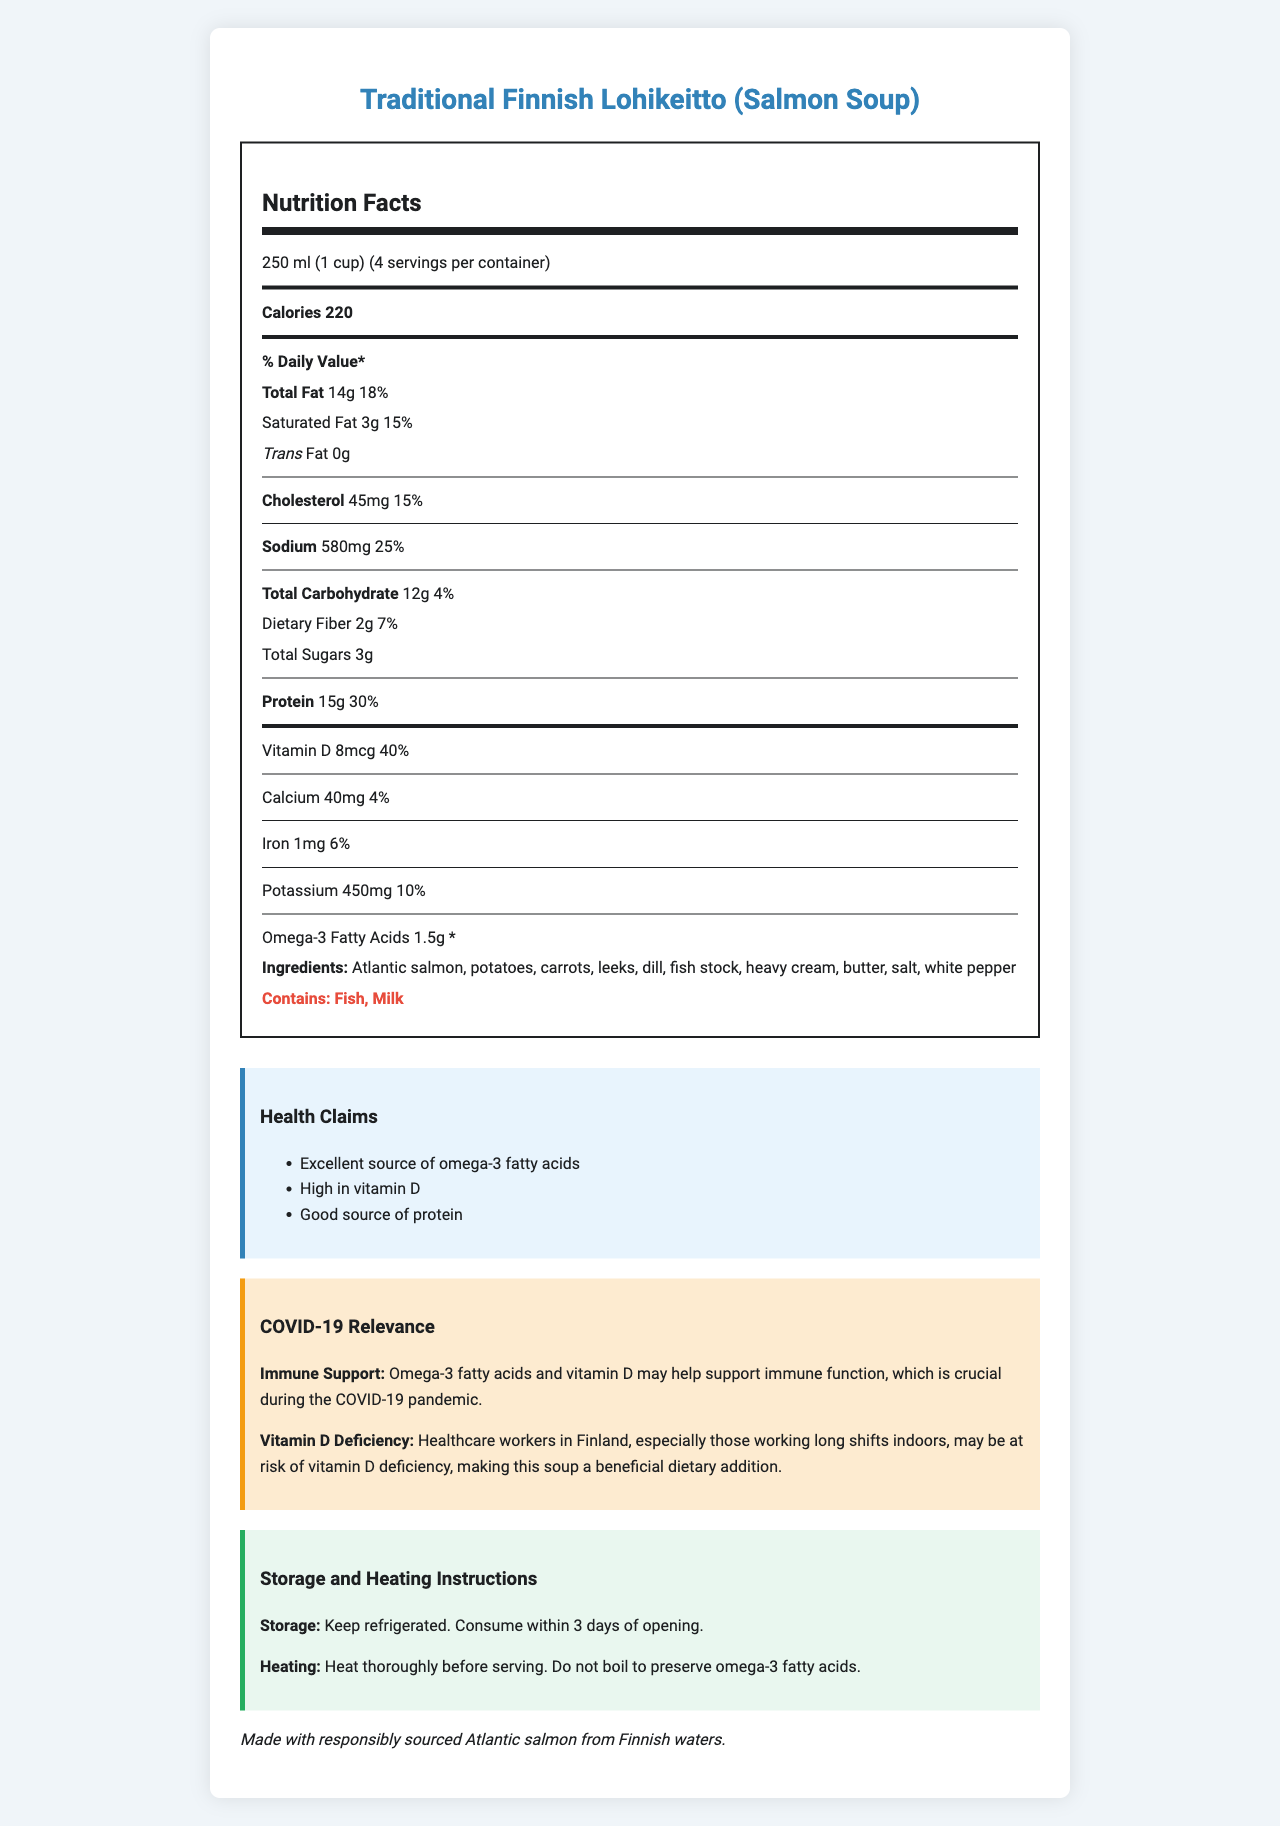what is the serving size? The document specifies that the serving size is 250 ml (1 cup).
Answer: 250 ml (1 cup) how many servings per container? The document states that there are 4 servings per container.
Answer: 4 servings how many calories are in one serving? The document indicates that each serving contains 220 calories.
Answer: 220 calories what is the total fat content per serving? The document lists the total fat per serving at 14g.
Answer: 14g how much vitamin D is provided per serving? The document details that there are 8 mcg of vitamin D per serving.
Answer: 8 mcg what is the main ingredient in the soup? The document lists Atlantic salmon as the first ingredient.
Answer: Atlantic salmon what allergens are present in the soup? The document specifies that the soup contains fish and milk as allergens.
Answer: Fish, Milk which component has the highest percentage of daily value? A. Vitamin D B. Sodium C. Calcium D. Protein The document shows that vitamin D has a 40% daily value, which is the highest among the mentioned components.
Answer: A. Vitamin D how should the soup be stored? The storage instructions advise keeping the soup refrigerated and consuming it within 3 days of opening.
Answer: Keep refrigerated. Consume within 3 days of opening. which of the following is NOT a health claim made in the document? A. Supports heart health B. Excellent source of omega-3 fatty acids C. High in vitamin D D. Good source of protein The document lists excellent source of omega-3 fatty acids, high in vitamin D, and good source of protein as health claims, but does not mention supporting heart health.
Answer: A. Supports heart health does the soup help support immune function during the COVID-19 pandemic? The document states that omega-3 fatty acids and vitamin D may help support immune function, which is crucial during the COVID-19 pandemic.
Answer: Yes is there any information provided about the source of the salmon? The document mentions that the salmon is responsibly sourced from Finnish waters.
Answer: Yes how much is the daily recommended intake of vitamin D for adults according to the Finnish Food Authority? The document states that the Finnish Food Authority recommends a daily intake of 10 mcg of vitamin D for adults.
Answer: 10 mcg what is the percent daily value of sodium in one serving? The document indicates that the sodium content per serving is 25% of the daily value.
Answer: 25% how does the soup help healthcare workers in Finland? The document mentions that omega-3 and vitamin D may support immune function, important during the pandemic, and that healthcare workers may be at risk of vitamin D deficiency.
Answer: The soup can help support immune function with omega-3 and vitamin D and address potential vitamin D deficiency. how should the soup be heated? The heating instructions advise thoroughly heating but not boiling the soup to preserve omega-3 fatty acids.
Answer: Heat thoroughly before serving. Do not boil to preserve omega-3 fatty acids. what is the percent daily value of protein in the soup? The document mentions that the protein content per serving is 30% of the daily value.
Answer: 30% does the soup contain any trans fat? The document lists 0g of trans fat.
Answer: No what is the product name? The document is titled "Nutrition Facts: Traditional Finnish Lohikeitto (Salmon Soup)" indicating the product name.
Answer: Traditional Finnish Lohikeitto (Salmon Soup) is there any information about the environmental impact of the ingredients? The document only mentions that the salmon is responsibly sourced but does not detail the overall environmental impact.
Answer: Not enough information summarize the entire document. The document is an informative sheet on Traditional Finnish Salmon Soup, outlining serving details, nutritional facts, ingredients, storage, and heating instructions while emphasizing health benefits pertinent to current pandemic needs.
Answer: The document provides detailed nutritional information, health claims, allergen warnings, storage and heating instructions, and highlights the relevance of the soup's nutrients to immunity and health, especially during the COVID-19 pandemic. It emphasizes the omega-3 and vitamin D content, beneficial for healthcare workers. 